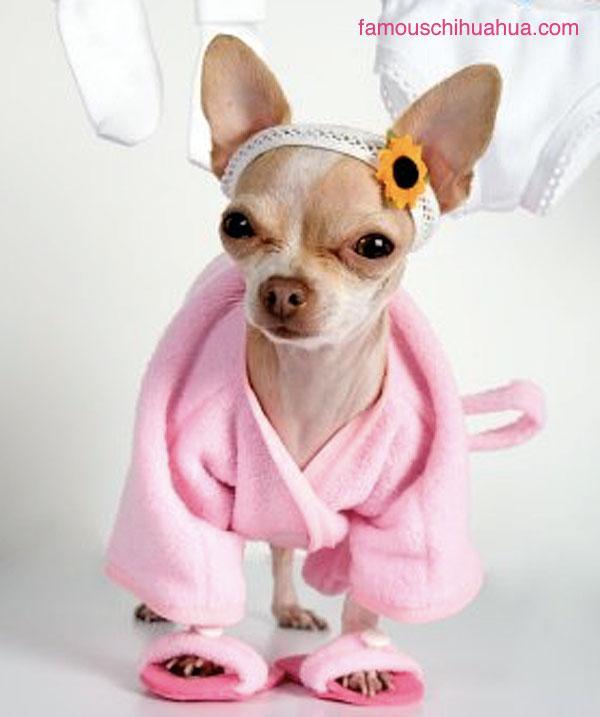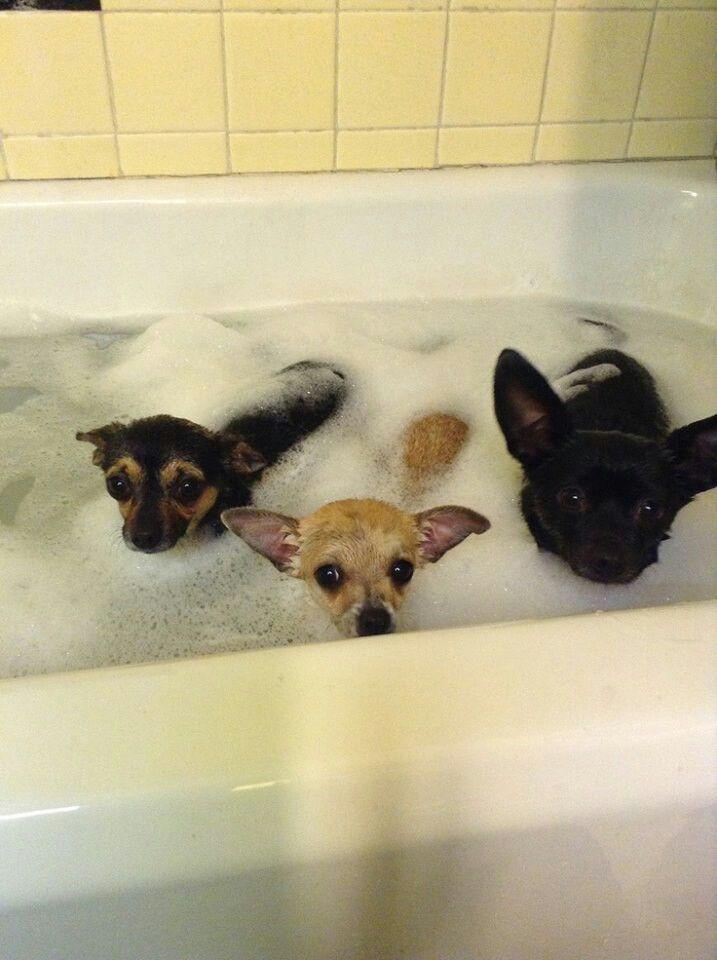The first image is the image on the left, the second image is the image on the right. Given the left and right images, does the statement "Both images show a small dog in contact with water." hold true? Answer yes or no. No. 